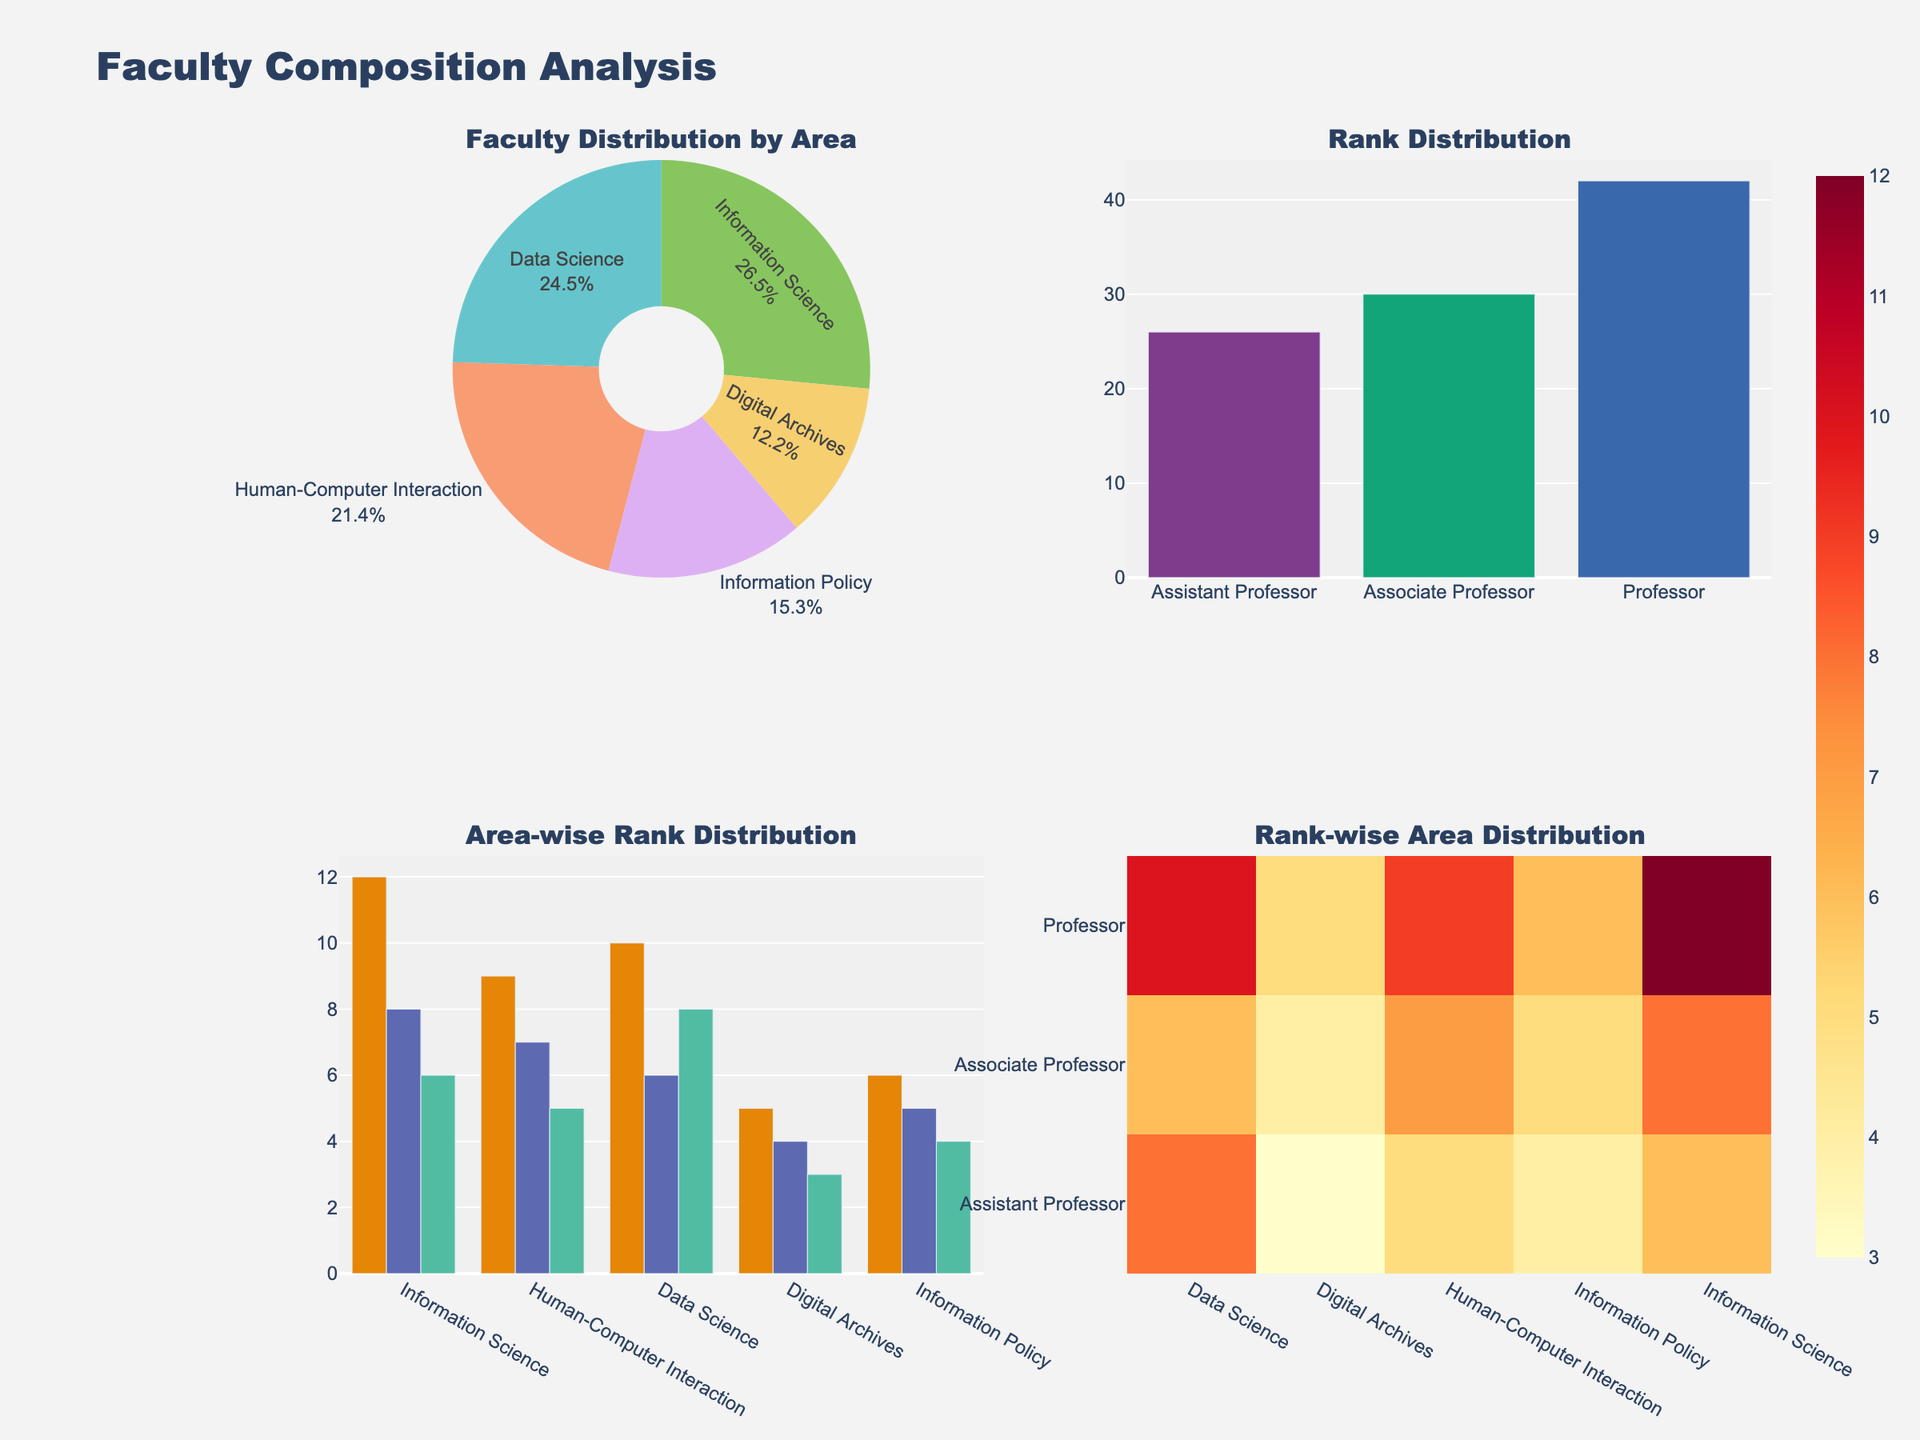What is the overall trend in literacy rates for the 5-14 age group in Shimla from 1970 to 2020? The line for the 5-14 age group in Shimla shows a rising trend from 45.2% in 1970 to 95.8% in 2020.
Answer: Rising How does the literacy rate of the 35+ age group in Kangra in 1990 compare to that in 2020? In 1990, the literacy rate for the 35+ age group in Kangra was 56.2%. By 2020, this rate had increased to 89.7%. Thus, the literacy rate for this age group improved by 33.5%.
Answer: Increased by 33.5% Which age group in Shimla had the highest literacy rate in 2010? In 2010, the 15-24 age group in Shimla had the highest literacy rate, which was 96.7%.
Answer: 15-24 age group Between Shimla and Kangra, which district had a higher literacy rate for the 5-14 age group in 2020, and what was the difference? In 2020, the literacy rates for the 5-14 age group were 95.8% in Shimla and 94.5% in Kangra. Shimla had a higher literacy rate by 1.3%.
Answer: Shimla; 1.3% How did the literacy rate for the 25-34 age group change in Kangra from 1970 to 2020? In 1970, the literacy rate for the 25-34 age group in Kangra was 50.2%. By 2020, it had risen to 96.8%, showing an increase of 46.6%.
Answer: Increased by 46.6% Compare the trends of the 15-24 age group literacy rates in both districts from 1970 to 2020. From 1970 to 2020, both Shimla and Kangra showed an increasing trend for the 15-24 age group. In Shimla, it increased from 62.8% to 98.9%, and in Kangra, it rose from 58.3% to 98.1%. Both districts show significant and parallel improvements over the years.
Answer: Both increased significantly What is the average literacy rate for the 35+ age group in Shimla across all the years presented? The literacy rates for the 35+ age group in Shimla are 38.9%, 59.6%, 82.5%, and 91.3% for the years 1970, 1990, 2010, and 2020 respectively. The average is calculated as (38.9 + 59.6 + 82.5 + 91.3) / 4 = 68.075%.
Answer: 68.075% Which district shows a more substantial improvement in literacy rate for the 15-24 age group from 1970 to 2020? In 1970, Shimla had a literacy rate of 62.8%, which increased to 98.9% in 2020. In Kangra, it went from 58.3% to 98.1%. The improvement in Shimla is 36.1%, while in Kangra, it is 39.8%. Thus, Kangra shows a slightly more substantial improvement.
Answer: Kangra What was the literacy rate of the 25-34 age group in Shimla in 1990, and how did it change by 2010? The literacy rate for the 25-34 age group in Shimla in 1990 was 75.9%. By 2010, it had increased to 92.8%, showing an increase of 16.9%.
Answer: Increased by 16.9% How do the literacy rates for the 5-14 age group in Kangra compare between 1970, 1990, 2010, and 2020? The literacy rates for the 5-14 age group in Kangra were 42.1% in 1970, 65.8% in 1990, 87.9% in 2010, and 94.5% in 2020. These rates show a consistent upward trend over the years.
Answer: Consistently increasing 